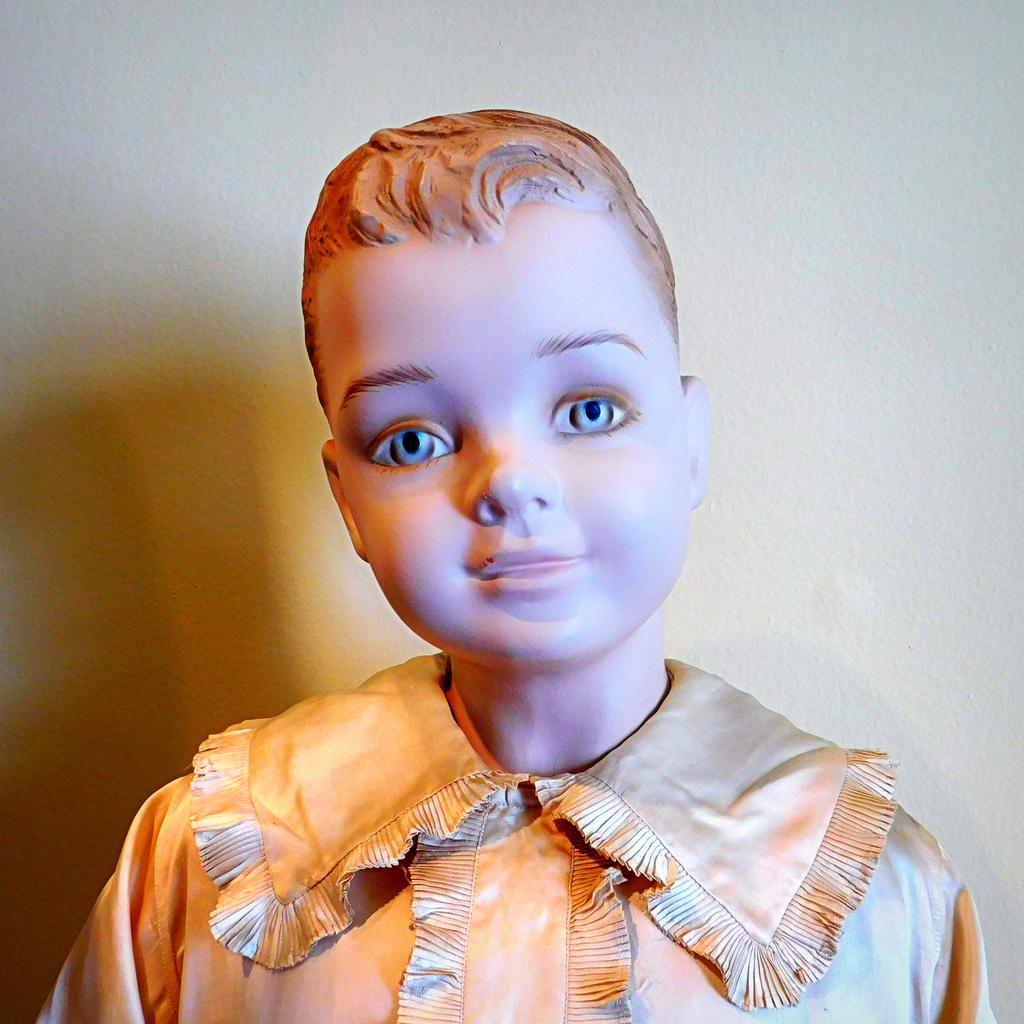What is the main subject of the image? There is a figurine of a boy in the image. What is the boy wearing? The boy is wearing a gold dress. What can be seen in the background of the image? There is a wall in the background of the image. What color is the wall? The wall is white. Where is the shadow of the figurine visible in the image? The shadow of the figurine is visible on the left side of the image. What is the income of the boy's sister in the image? There is no mention of a sister or income in the image, as it only features a figurine of a boy and a white wall in the background. 